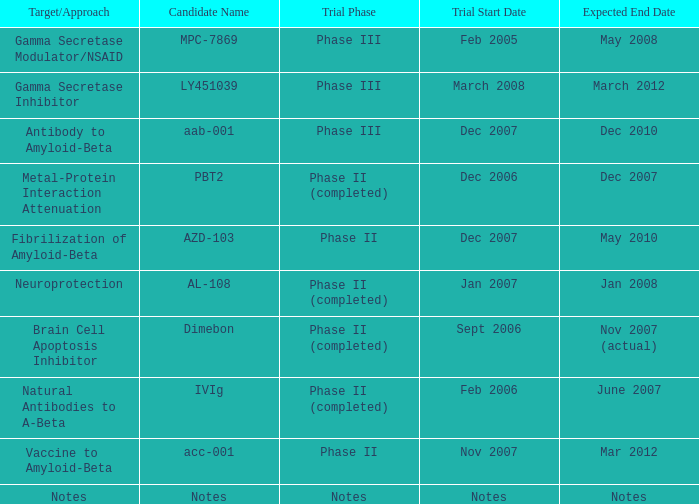What is Expected End Date, when Target/Approach is Notes? Notes. Can you parse all the data within this table? {'header': ['Target/Approach', 'Candidate Name', 'Trial Phase', 'Trial Start Date', 'Expected End Date'], 'rows': [['Gamma Secretase Modulator/NSAID', 'MPC-7869', 'Phase III', 'Feb 2005', 'May 2008'], ['Gamma Secretase Inhibitor', 'LY451039', 'Phase III', 'March 2008', 'March 2012'], ['Antibody to Amyloid-Beta', 'aab-001', 'Phase III', 'Dec 2007', 'Dec 2010'], ['Metal-Protein Interaction Attenuation', 'PBT2', 'Phase II (completed)', 'Dec 2006', 'Dec 2007'], ['Fibrilization of Amyloid-Beta', 'AZD-103', 'Phase II', 'Dec 2007', 'May 2010'], ['Neuroprotection', 'AL-108', 'Phase II (completed)', 'Jan 2007', 'Jan 2008'], ['Brain Cell Apoptosis Inhibitor', 'Dimebon', 'Phase II (completed)', 'Sept 2006', 'Nov 2007 (actual)'], ['Natural Antibodies to A-Beta', 'IVIg', 'Phase II (completed)', 'Feb 2006', 'June 2007'], ['Vaccine to Amyloid-Beta', 'acc-001', 'Phase II', 'Nov 2007', 'Mar 2012'], ['Notes', 'Notes', 'Notes', 'Notes', 'Notes']]} 